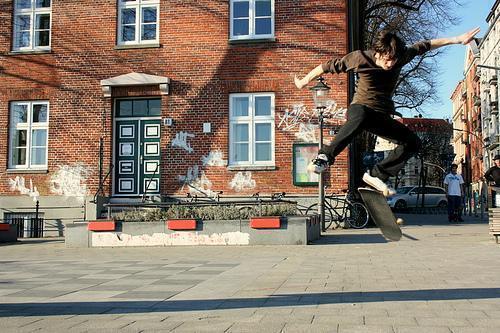The concrete planter has how many orange boards on the side?
Select the correct answer and articulate reasoning with the following format: 'Answer: answer
Rationale: rationale.'
Options: Two, five, four, three. Answer: three.
Rationale: There are a trio of orange boards on the concrete planter. 